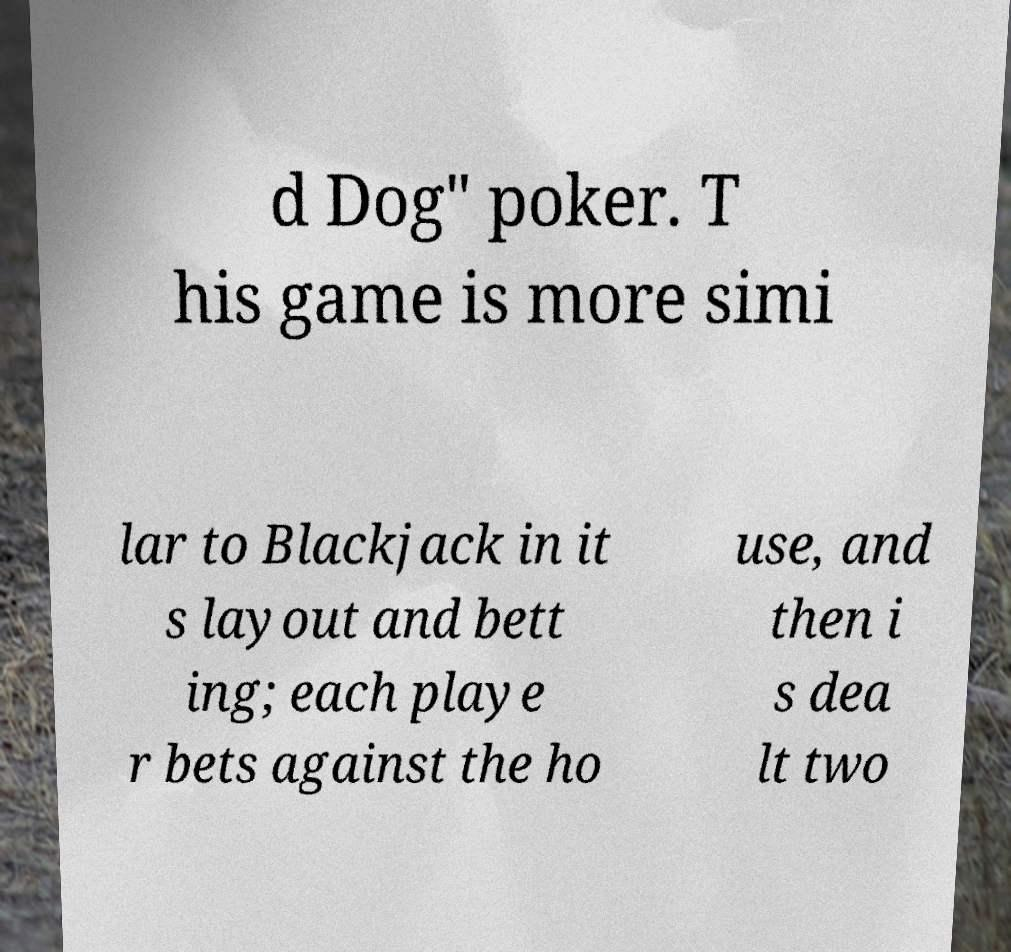Please identify and transcribe the text found in this image. d Dog" poker. T his game is more simi lar to Blackjack in it s layout and bett ing; each playe r bets against the ho use, and then i s dea lt two 